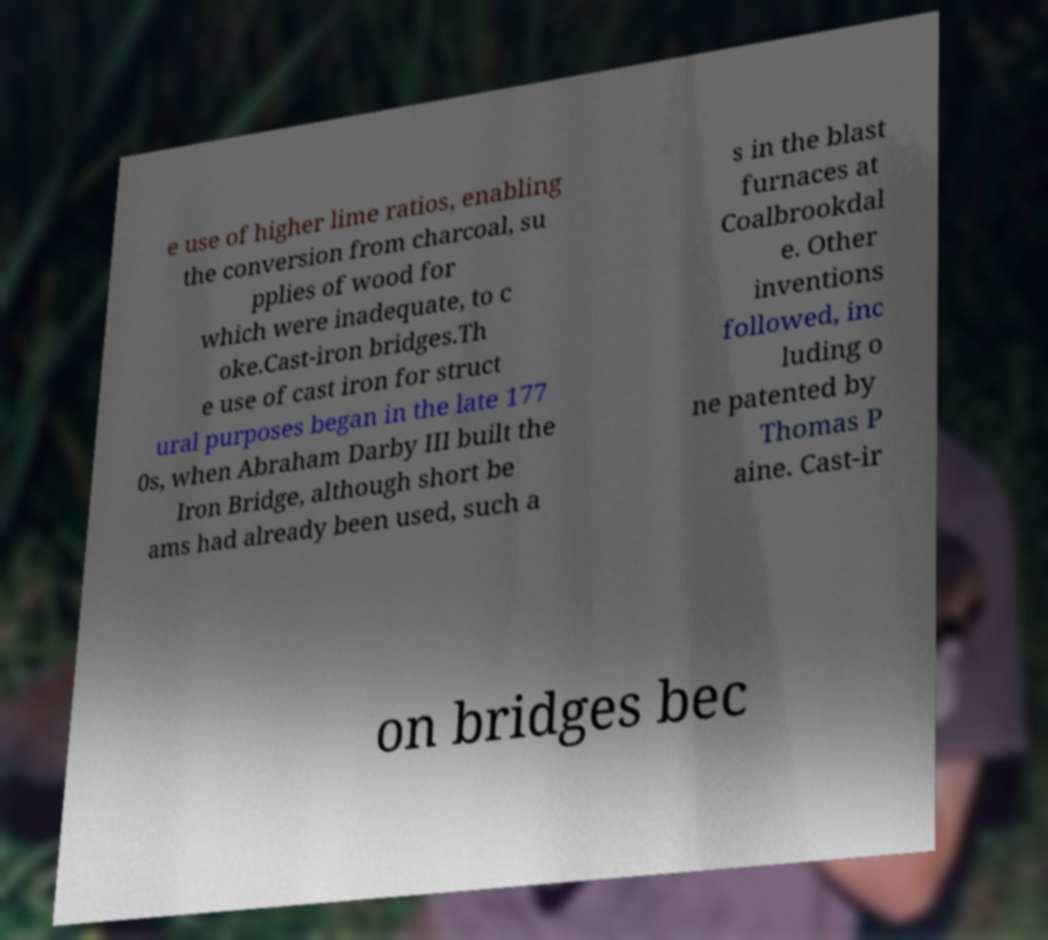There's text embedded in this image that I need extracted. Can you transcribe it verbatim? e use of higher lime ratios, enabling the conversion from charcoal, su pplies of wood for which were inadequate, to c oke.Cast-iron bridges.Th e use of cast iron for struct ural purposes began in the late 177 0s, when Abraham Darby III built the Iron Bridge, although short be ams had already been used, such a s in the blast furnaces at Coalbrookdal e. Other inventions followed, inc luding o ne patented by Thomas P aine. Cast-ir on bridges bec 